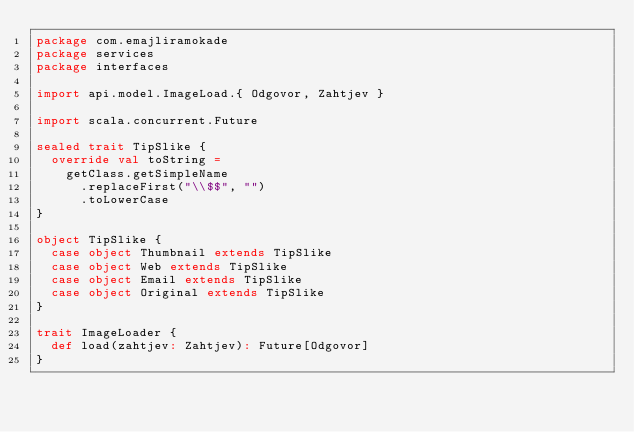<code> <loc_0><loc_0><loc_500><loc_500><_Scala_>package com.emajliramokade
package services
package interfaces

import api.model.ImageLoad.{ Odgovor, Zahtjev }

import scala.concurrent.Future

sealed trait TipSlike {
  override val toString =
    getClass.getSimpleName
      .replaceFirst("\\$$", "")
      .toLowerCase
}

object TipSlike {
  case object Thumbnail extends TipSlike
  case object Web extends TipSlike
  case object Email extends TipSlike
  case object Original extends TipSlike
}

trait ImageLoader {
  def load(zahtjev: Zahtjev): Future[Odgovor]
}
</code> 